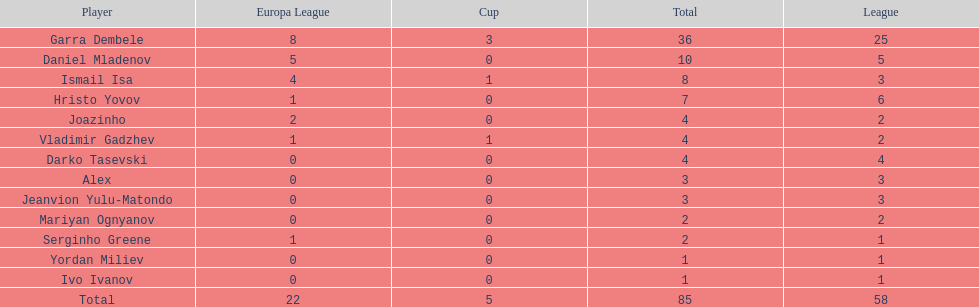Which total is higher, the europa league total or the league total? League. 